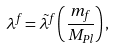Convert formula to latex. <formula><loc_0><loc_0><loc_500><loc_500>\lambda ^ { f } = \tilde { \lambda } ^ { f } \left ( \frac { m _ { f } } { M _ { P l } } \right ) ,</formula> 